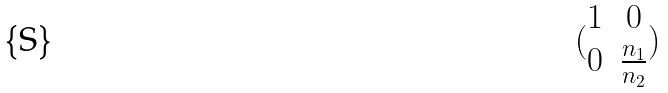<formula> <loc_0><loc_0><loc_500><loc_500>( \begin{matrix} 1 & 0 \\ 0 & \frac { n _ { 1 } } { n _ { 2 } } \end{matrix} )</formula> 